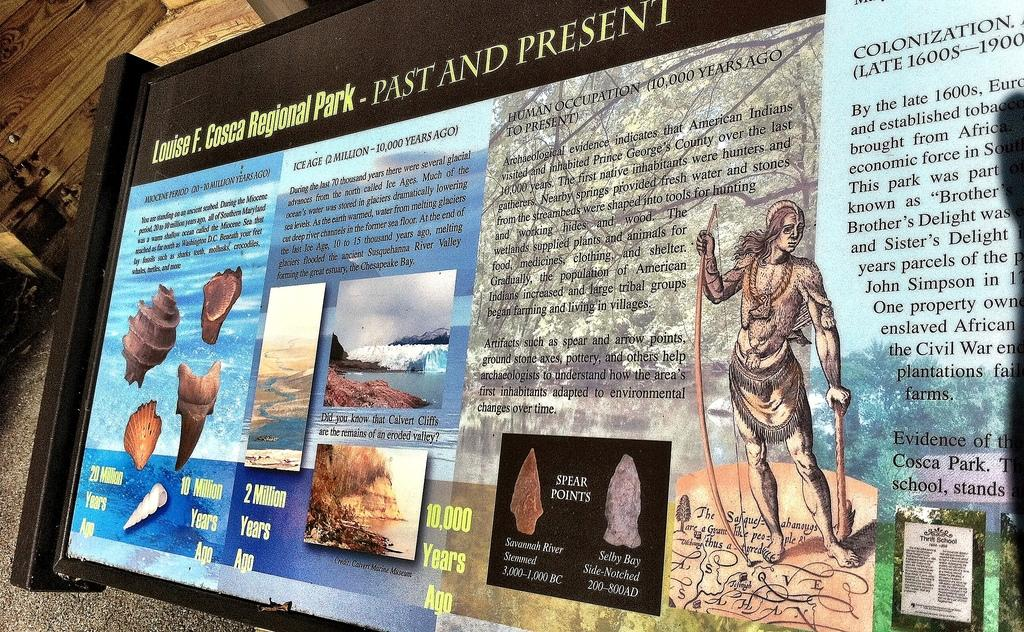<image>
Provide a brief description of the given image. "Louise F. Cosca Regional Park" is displayed at the top of this information area. 